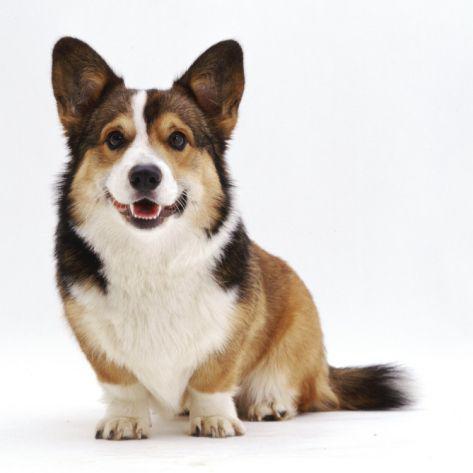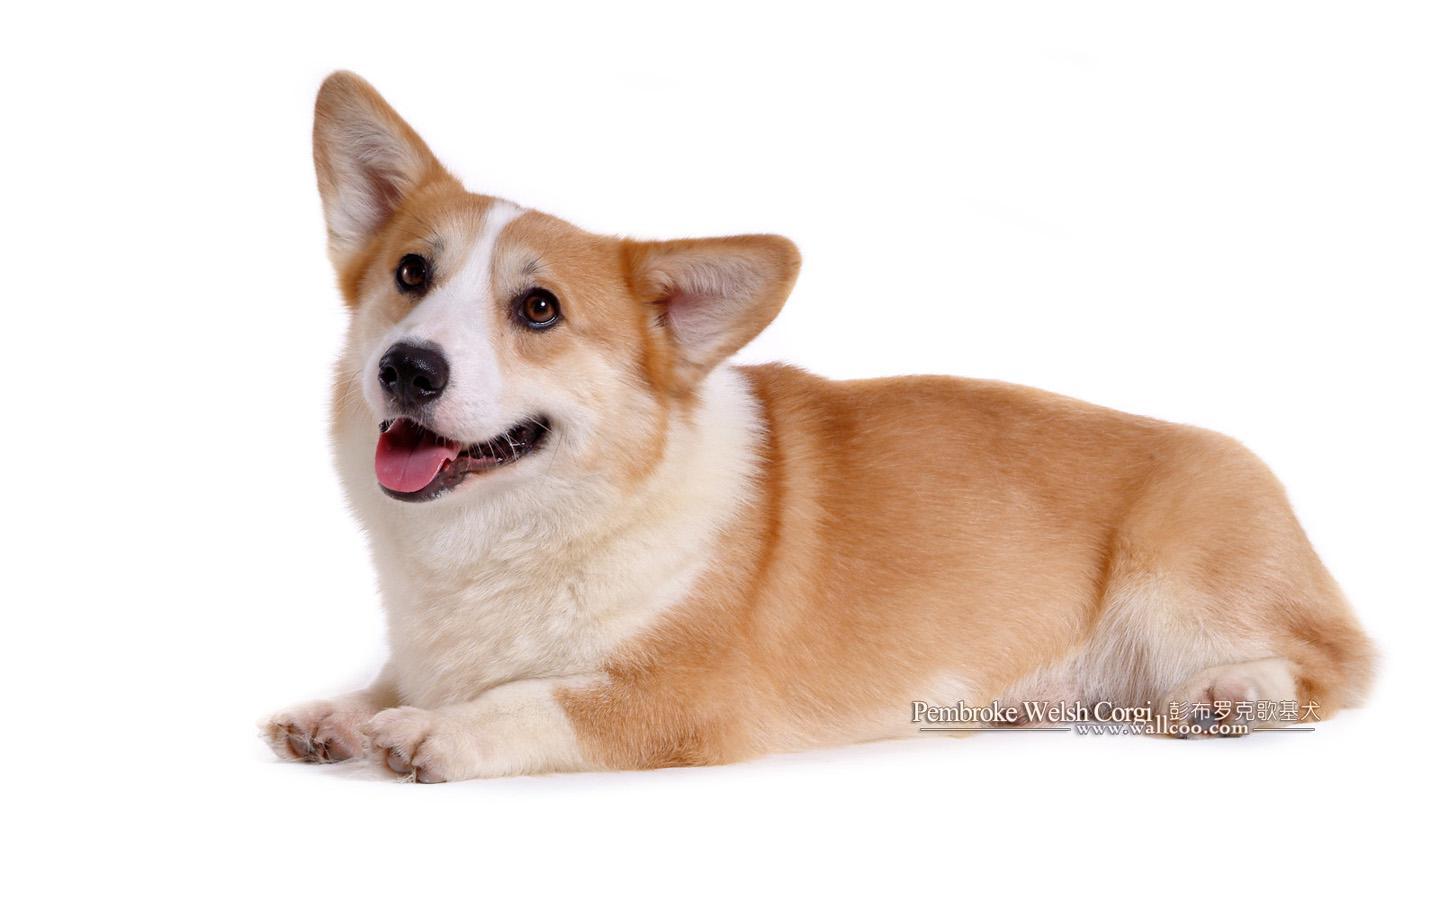The first image is the image on the left, the second image is the image on the right. Examine the images to the left and right. Is the description "One dog is sitting and the other is laying flat with paws forward." accurate? Answer yes or no. Yes. 